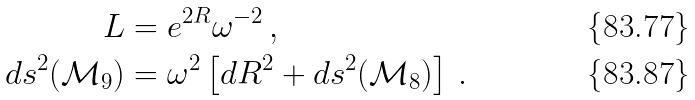<formula> <loc_0><loc_0><loc_500><loc_500>L & = e ^ { 2 R } \omega ^ { - 2 } \, , \\ d s ^ { 2 } ( \mathcal { M } _ { 9 } ) & = \omega ^ { 2 } \left [ d R ^ { 2 } + d s ^ { 2 } ( \mathcal { M } _ { 8 } ) \right ] \, .</formula> 